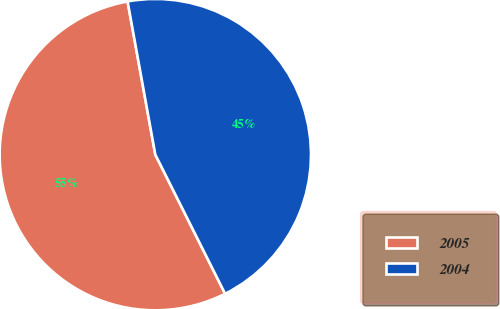Convert chart to OTSL. <chart><loc_0><loc_0><loc_500><loc_500><pie_chart><fcel>2005<fcel>2004<nl><fcel>54.55%<fcel>45.45%<nl></chart> 